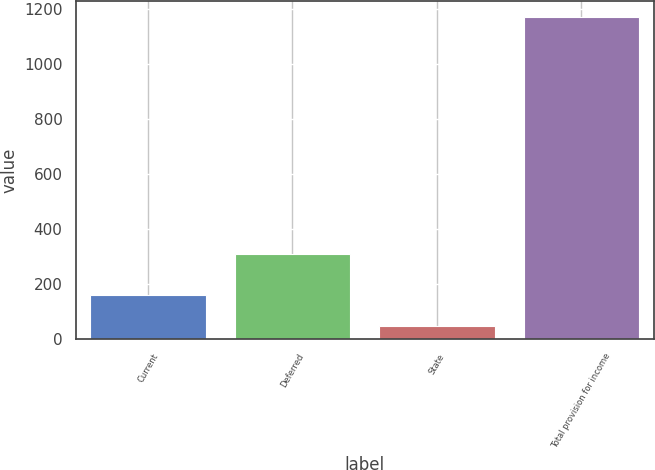<chart> <loc_0><loc_0><loc_500><loc_500><bar_chart><fcel>Current<fcel>Deferred<fcel>State<fcel>Total provision for income<nl><fcel>158.7<fcel>309<fcel>46<fcel>1173<nl></chart> 